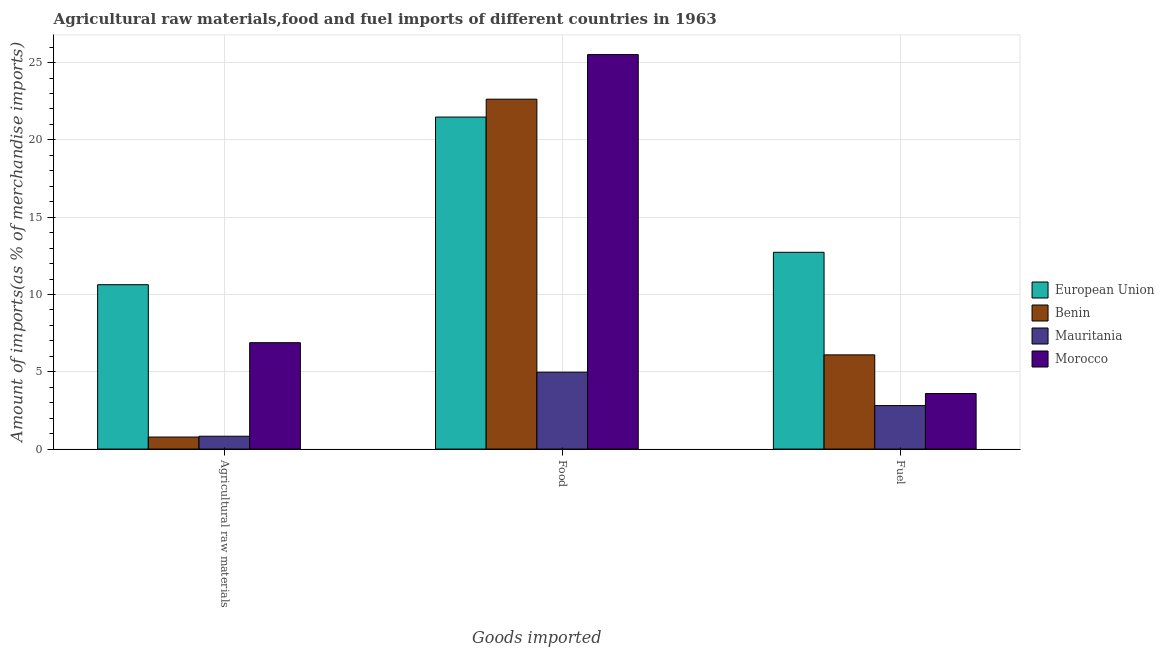How many different coloured bars are there?
Offer a terse response. 4. What is the label of the 2nd group of bars from the left?
Your answer should be compact. Food. What is the percentage of fuel imports in Benin?
Keep it short and to the point. 6.09. Across all countries, what is the maximum percentage of food imports?
Your response must be concise. 25.52. Across all countries, what is the minimum percentage of fuel imports?
Ensure brevity in your answer.  2.81. In which country was the percentage of food imports maximum?
Provide a succinct answer. Morocco. In which country was the percentage of food imports minimum?
Offer a terse response. Mauritania. What is the total percentage of raw materials imports in the graph?
Provide a succinct answer. 19.13. What is the difference between the percentage of fuel imports in European Union and that in Mauritania?
Offer a very short reply. 9.92. What is the difference between the percentage of raw materials imports in Mauritania and the percentage of fuel imports in Morocco?
Make the answer very short. -2.76. What is the average percentage of food imports per country?
Your response must be concise. 18.65. What is the difference between the percentage of food imports and percentage of raw materials imports in Mauritania?
Provide a succinct answer. 4.14. In how many countries, is the percentage of food imports greater than 12 %?
Ensure brevity in your answer.  3. What is the ratio of the percentage of food imports in Morocco to that in Mauritania?
Make the answer very short. 5.13. Is the percentage of raw materials imports in European Union less than that in Benin?
Offer a very short reply. No. Is the difference between the percentage of fuel imports in Benin and Morocco greater than the difference between the percentage of raw materials imports in Benin and Morocco?
Provide a succinct answer. Yes. What is the difference between the highest and the second highest percentage of fuel imports?
Your response must be concise. 6.63. What is the difference between the highest and the lowest percentage of food imports?
Offer a terse response. 20.54. Is it the case that in every country, the sum of the percentage of raw materials imports and percentage of food imports is greater than the percentage of fuel imports?
Provide a short and direct response. Yes. Are all the bars in the graph horizontal?
Provide a short and direct response. No. What is the difference between two consecutive major ticks on the Y-axis?
Your answer should be compact. 5. Does the graph contain any zero values?
Provide a short and direct response. No. Does the graph contain grids?
Ensure brevity in your answer.  Yes. How many legend labels are there?
Your response must be concise. 4. What is the title of the graph?
Give a very brief answer. Agricultural raw materials,food and fuel imports of different countries in 1963. What is the label or title of the X-axis?
Provide a short and direct response. Goods imported. What is the label or title of the Y-axis?
Give a very brief answer. Amount of imports(as % of merchandise imports). What is the Amount of imports(as % of merchandise imports) in European Union in Agricultural raw materials?
Keep it short and to the point. 10.63. What is the Amount of imports(as % of merchandise imports) in Benin in Agricultural raw materials?
Provide a short and direct response. 0.78. What is the Amount of imports(as % of merchandise imports) of Mauritania in Agricultural raw materials?
Provide a short and direct response. 0.83. What is the Amount of imports(as % of merchandise imports) in Morocco in Agricultural raw materials?
Offer a very short reply. 6.88. What is the Amount of imports(as % of merchandise imports) of European Union in Food?
Make the answer very short. 21.48. What is the Amount of imports(as % of merchandise imports) of Benin in Food?
Provide a short and direct response. 22.63. What is the Amount of imports(as % of merchandise imports) in Mauritania in Food?
Your answer should be compact. 4.97. What is the Amount of imports(as % of merchandise imports) of Morocco in Food?
Offer a terse response. 25.52. What is the Amount of imports(as % of merchandise imports) of European Union in Fuel?
Keep it short and to the point. 12.73. What is the Amount of imports(as % of merchandise imports) of Benin in Fuel?
Your answer should be compact. 6.09. What is the Amount of imports(as % of merchandise imports) in Mauritania in Fuel?
Your answer should be compact. 2.81. What is the Amount of imports(as % of merchandise imports) in Morocco in Fuel?
Keep it short and to the point. 3.59. Across all Goods imported, what is the maximum Amount of imports(as % of merchandise imports) in European Union?
Your response must be concise. 21.48. Across all Goods imported, what is the maximum Amount of imports(as % of merchandise imports) in Benin?
Keep it short and to the point. 22.63. Across all Goods imported, what is the maximum Amount of imports(as % of merchandise imports) of Mauritania?
Offer a very short reply. 4.97. Across all Goods imported, what is the maximum Amount of imports(as % of merchandise imports) of Morocco?
Make the answer very short. 25.52. Across all Goods imported, what is the minimum Amount of imports(as % of merchandise imports) of European Union?
Keep it short and to the point. 10.63. Across all Goods imported, what is the minimum Amount of imports(as % of merchandise imports) in Benin?
Provide a succinct answer. 0.78. Across all Goods imported, what is the minimum Amount of imports(as % of merchandise imports) in Mauritania?
Your response must be concise. 0.83. Across all Goods imported, what is the minimum Amount of imports(as % of merchandise imports) of Morocco?
Provide a succinct answer. 3.59. What is the total Amount of imports(as % of merchandise imports) in European Union in the graph?
Your answer should be compact. 44.84. What is the total Amount of imports(as % of merchandise imports) of Benin in the graph?
Your answer should be compact. 29.51. What is the total Amount of imports(as % of merchandise imports) of Mauritania in the graph?
Provide a short and direct response. 8.62. What is the total Amount of imports(as % of merchandise imports) in Morocco in the graph?
Your response must be concise. 35.99. What is the difference between the Amount of imports(as % of merchandise imports) of European Union in Agricultural raw materials and that in Food?
Your answer should be very brief. -10.84. What is the difference between the Amount of imports(as % of merchandise imports) in Benin in Agricultural raw materials and that in Food?
Your response must be concise. -21.86. What is the difference between the Amount of imports(as % of merchandise imports) in Mauritania in Agricultural raw materials and that in Food?
Provide a succinct answer. -4.14. What is the difference between the Amount of imports(as % of merchandise imports) of Morocco in Agricultural raw materials and that in Food?
Offer a terse response. -18.64. What is the difference between the Amount of imports(as % of merchandise imports) of European Union in Agricultural raw materials and that in Fuel?
Give a very brief answer. -2.1. What is the difference between the Amount of imports(as % of merchandise imports) of Benin in Agricultural raw materials and that in Fuel?
Your answer should be compact. -5.32. What is the difference between the Amount of imports(as % of merchandise imports) in Mauritania in Agricultural raw materials and that in Fuel?
Your answer should be very brief. -1.98. What is the difference between the Amount of imports(as % of merchandise imports) in Morocco in Agricultural raw materials and that in Fuel?
Make the answer very short. 3.29. What is the difference between the Amount of imports(as % of merchandise imports) of European Union in Food and that in Fuel?
Keep it short and to the point. 8.75. What is the difference between the Amount of imports(as % of merchandise imports) of Benin in Food and that in Fuel?
Your answer should be very brief. 16.54. What is the difference between the Amount of imports(as % of merchandise imports) in Mauritania in Food and that in Fuel?
Offer a very short reply. 2.16. What is the difference between the Amount of imports(as % of merchandise imports) of Morocco in Food and that in Fuel?
Provide a succinct answer. 21.92. What is the difference between the Amount of imports(as % of merchandise imports) of European Union in Agricultural raw materials and the Amount of imports(as % of merchandise imports) of Benin in Food?
Keep it short and to the point. -12. What is the difference between the Amount of imports(as % of merchandise imports) in European Union in Agricultural raw materials and the Amount of imports(as % of merchandise imports) in Mauritania in Food?
Offer a terse response. 5.66. What is the difference between the Amount of imports(as % of merchandise imports) of European Union in Agricultural raw materials and the Amount of imports(as % of merchandise imports) of Morocco in Food?
Your answer should be compact. -14.88. What is the difference between the Amount of imports(as % of merchandise imports) in Benin in Agricultural raw materials and the Amount of imports(as % of merchandise imports) in Mauritania in Food?
Your answer should be very brief. -4.2. What is the difference between the Amount of imports(as % of merchandise imports) of Benin in Agricultural raw materials and the Amount of imports(as % of merchandise imports) of Morocco in Food?
Your answer should be very brief. -24.74. What is the difference between the Amount of imports(as % of merchandise imports) in Mauritania in Agricultural raw materials and the Amount of imports(as % of merchandise imports) in Morocco in Food?
Provide a short and direct response. -24.69. What is the difference between the Amount of imports(as % of merchandise imports) of European Union in Agricultural raw materials and the Amount of imports(as % of merchandise imports) of Benin in Fuel?
Your response must be concise. 4.54. What is the difference between the Amount of imports(as % of merchandise imports) of European Union in Agricultural raw materials and the Amount of imports(as % of merchandise imports) of Mauritania in Fuel?
Keep it short and to the point. 7.82. What is the difference between the Amount of imports(as % of merchandise imports) of European Union in Agricultural raw materials and the Amount of imports(as % of merchandise imports) of Morocco in Fuel?
Make the answer very short. 7.04. What is the difference between the Amount of imports(as % of merchandise imports) of Benin in Agricultural raw materials and the Amount of imports(as % of merchandise imports) of Mauritania in Fuel?
Your answer should be very brief. -2.04. What is the difference between the Amount of imports(as % of merchandise imports) in Benin in Agricultural raw materials and the Amount of imports(as % of merchandise imports) in Morocco in Fuel?
Provide a short and direct response. -2.82. What is the difference between the Amount of imports(as % of merchandise imports) in Mauritania in Agricultural raw materials and the Amount of imports(as % of merchandise imports) in Morocco in Fuel?
Provide a short and direct response. -2.76. What is the difference between the Amount of imports(as % of merchandise imports) of European Union in Food and the Amount of imports(as % of merchandise imports) of Benin in Fuel?
Keep it short and to the point. 15.38. What is the difference between the Amount of imports(as % of merchandise imports) of European Union in Food and the Amount of imports(as % of merchandise imports) of Mauritania in Fuel?
Keep it short and to the point. 18.66. What is the difference between the Amount of imports(as % of merchandise imports) in European Union in Food and the Amount of imports(as % of merchandise imports) in Morocco in Fuel?
Offer a terse response. 17.88. What is the difference between the Amount of imports(as % of merchandise imports) in Benin in Food and the Amount of imports(as % of merchandise imports) in Mauritania in Fuel?
Provide a succinct answer. 19.82. What is the difference between the Amount of imports(as % of merchandise imports) of Benin in Food and the Amount of imports(as % of merchandise imports) of Morocco in Fuel?
Offer a very short reply. 19.04. What is the difference between the Amount of imports(as % of merchandise imports) of Mauritania in Food and the Amount of imports(as % of merchandise imports) of Morocco in Fuel?
Provide a short and direct response. 1.38. What is the average Amount of imports(as % of merchandise imports) of European Union per Goods imported?
Keep it short and to the point. 14.95. What is the average Amount of imports(as % of merchandise imports) in Benin per Goods imported?
Ensure brevity in your answer.  9.84. What is the average Amount of imports(as % of merchandise imports) in Mauritania per Goods imported?
Your response must be concise. 2.87. What is the average Amount of imports(as % of merchandise imports) of Morocco per Goods imported?
Offer a terse response. 12. What is the difference between the Amount of imports(as % of merchandise imports) of European Union and Amount of imports(as % of merchandise imports) of Benin in Agricultural raw materials?
Make the answer very short. 9.86. What is the difference between the Amount of imports(as % of merchandise imports) of European Union and Amount of imports(as % of merchandise imports) of Mauritania in Agricultural raw materials?
Provide a succinct answer. 9.8. What is the difference between the Amount of imports(as % of merchandise imports) in European Union and Amount of imports(as % of merchandise imports) in Morocco in Agricultural raw materials?
Provide a succinct answer. 3.75. What is the difference between the Amount of imports(as % of merchandise imports) in Benin and Amount of imports(as % of merchandise imports) in Mauritania in Agricultural raw materials?
Ensure brevity in your answer.  -0.05. What is the difference between the Amount of imports(as % of merchandise imports) in Benin and Amount of imports(as % of merchandise imports) in Morocco in Agricultural raw materials?
Provide a short and direct response. -6.1. What is the difference between the Amount of imports(as % of merchandise imports) in Mauritania and Amount of imports(as % of merchandise imports) in Morocco in Agricultural raw materials?
Make the answer very short. -6.05. What is the difference between the Amount of imports(as % of merchandise imports) in European Union and Amount of imports(as % of merchandise imports) in Benin in Food?
Your answer should be very brief. -1.16. What is the difference between the Amount of imports(as % of merchandise imports) in European Union and Amount of imports(as % of merchandise imports) in Mauritania in Food?
Keep it short and to the point. 16.5. What is the difference between the Amount of imports(as % of merchandise imports) in European Union and Amount of imports(as % of merchandise imports) in Morocco in Food?
Give a very brief answer. -4.04. What is the difference between the Amount of imports(as % of merchandise imports) in Benin and Amount of imports(as % of merchandise imports) in Mauritania in Food?
Ensure brevity in your answer.  17.66. What is the difference between the Amount of imports(as % of merchandise imports) in Benin and Amount of imports(as % of merchandise imports) in Morocco in Food?
Provide a succinct answer. -2.88. What is the difference between the Amount of imports(as % of merchandise imports) in Mauritania and Amount of imports(as % of merchandise imports) in Morocco in Food?
Make the answer very short. -20.54. What is the difference between the Amount of imports(as % of merchandise imports) in European Union and Amount of imports(as % of merchandise imports) in Benin in Fuel?
Your response must be concise. 6.63. What is the difference between the Amount of imports(as % of merchandise imports) of European Union and Amount of imports(as % of merchandise imports) of Mauritania in Fuel?
Make the answer very short. 9.92. What is the difference between the Amount of imports(as % of merchandise imports) of European Union and Amount of imports(as % of merchandise imports) of Morocco in Fuel?
Your answer should be compact. 9.13. What is the difference between the Amount of imports(as % of merchandise imports) of Benin and Amount of imports(as % of merchandise imports) of Mauritania in Fuel?
Your answer should be compact. 3.28. What is the difference between the Amount of imports(as % of merchandise imports) in Benin and Amount of imports(as % of merchandise imports) in Morocco in Fuel?
Offer a terse response. 2.5. What is the difference between the Amount of imports(as % of merchandise imports) in Mauritania and Amount of imports(as % of merchandise imports) in Morocco in Fuel?
Make the answer very short. -0.78. What is the ratio of the Amount of imports(as % of merchandise imports) in European Union in Agricultural raw materials to that in Food?
Your answer should be compact. 0.5. What is the ratio of the Amount of imports(as % of merchandise imports) of Benin in Agricultural raw materials to that in Food?
Ensure brevity in your answer.  0.03. What is the ratio of the Amount of imports(as % of merchandise imports) in Mauritania in Agricultural raw materials to that in Food?
Offer a terse response. 0.17. What is the ratio of the Amount of imports(as % of merchandise imports) in Morocco in Agricultural raw materials to that in Food?
Ensure brevity in your answer.  0.27. What is the ratio of the Amount of imports(as % of merchandise imports) of European Union in Agricultural raw materials to that in Fuel?
Ensure brevity in your answer.  0.84. What is the ratio of the Amount of imports(as % of merchandise imports) in Benin in Agricultural raw materials to that in Fuel?
Ensure brevity in your answer.  0.13. What is the ratio of the Amount of imports(as % of merchandise imports) in Mauritania in Agricultural raw materials to that in Fuel?
Ensure brevity in your answer.  0.3. What is the ratio of the Amount of imports(as % of merchandise imports) in Morocco in Agricultural raw materials to that in Fuel?
Offer a terse response. 1.91. What is the ratio of the Amount of imports(as % of merchandise imports) of European Union in Food to that in Fuel?
Your response must be concise. 1.69. What is the ratio of the Amount of imports(as % of merchandise imports) of Benin in Food to that in Fuel?
Keep it short and to the point. 3.71. What is the ratio of the Amount of imports(as % of merchandise imports) of Mauritania in Food to that in Fuel?
Provide a succinct answer. 1.77. What is the ratio of the Amount of imports(as % of merchandise imports) of Morocco in Food to that in Fuel?
Provide a short and direct response. 7.1. What is the difference between the highest and the second highest Amount of imports(as % of merchandise imports) of European Union?
Give a very brief answer. 8.75. What is the difference between the highest and the second highest Amount of imports(as % of merchandise imports) in Benin?
Provide a succinct answer. 16.54. What is the difference between the highest and the second highest Amount of imports(as % of merchandise imports) of Mauritania?
Your response must be concise. 2.16. What is the difference between the highest and the second highest Amount of imports(as % of merchandise imports) of Morocco?
Your answer should be very brief. 18.64. What is the difference between the highest and the lowest Amount of imports(as % of merchandise imports) in European Union?
Give a very brief answer. 10.84. What is the difference between the highest and the lowest Amount of imports(as % of merchandise imports) of Benin?
Your response must be concise. 21.86. What is the difference between the highest and the lowest Amount of imports(as % of merchandise imports) of Mauritania?
Provide a succinct answer. 4.14. What is the difference between the highest and the lowest Amount of imports(as % of merchandise imports) in Morocco?
Provide a short and direct response. 21.92. 